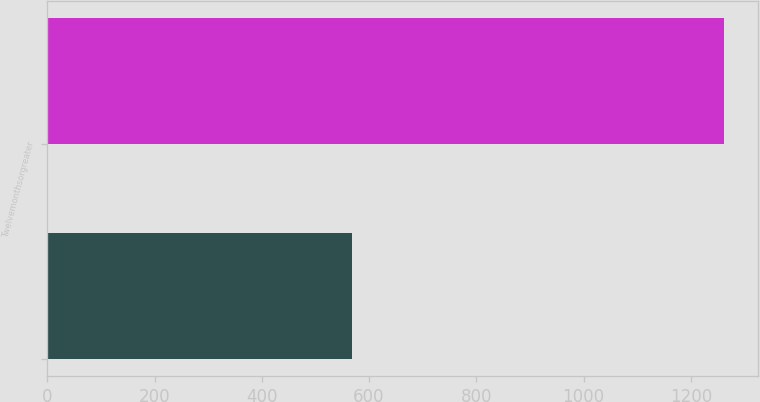<chart> <loc_0><loc_0><loc_500><loc_500><bar_chart><ecel><fcel>Twelvemonthsorgreater<nl><fcel>568<fcel>1262<nl></chart> 